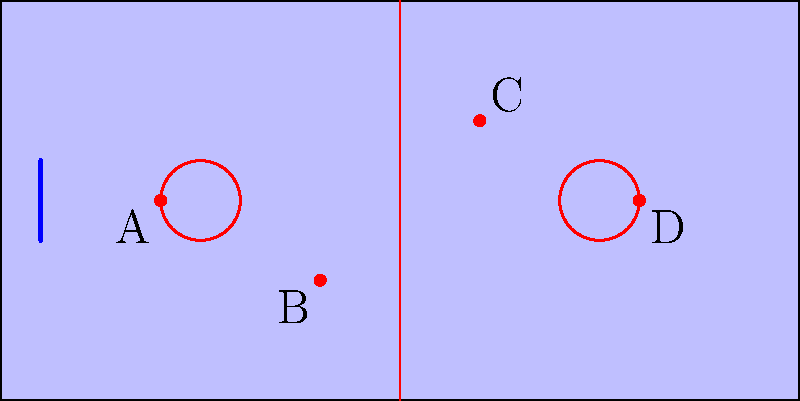Based on the positions of four players (A, B, C, and D) on the ice rink, which player is most likely to have the highest shot accuracy when attempting to score on the goal shown? Consider factors such as distance from the goal, angle of the shot, and potential defensive pressure. To determine which player is most likely to have the highest shot accuracy, we need to consider several factors:

1. Distance from the goal:
   Player A: Closest to the goal
   Player B: Second closest
   Player C: Third closest
   Player D: Furthest from the goal

2. Angle of the shot:
   Player A: Wide angle, slightly off-center
   Player B: Narrow angle, but closer to the goal
   Player C: Good angle, nearly straight-on
   Player D: Wide angle, far from the goal

3. Potential defensive pressure:
   Player A: Likely facing high pressure due to proximity to the goal
   Player B: Moderate pressure, but in a tight spot
   Player C: Potentially less pressure, with more open ice
   Player D: Least pressure, but furthest from the goal

Considering these factors:

1. Player A has the advantage of being closest to the goal, but the wide angle and potential defensive pressure could reduce accuracy.
2. Player B has a good position for a quick shot, but the narrow angle might limit shot options.
3. Player C has a favorable combination of distance, angle, and potential open ice, which could lead to higher accuracy.
4. Player D, while facing less pressure, is at a significant disadvantage due to distance and angle.

Given these considerations, Player C is most likely to have the highest shot accuracy. The combination of a good angle, reasonable distance, and potentially less defensive pressure provides the best opportunity for an accurate shot on goal.
Answer: Player C 